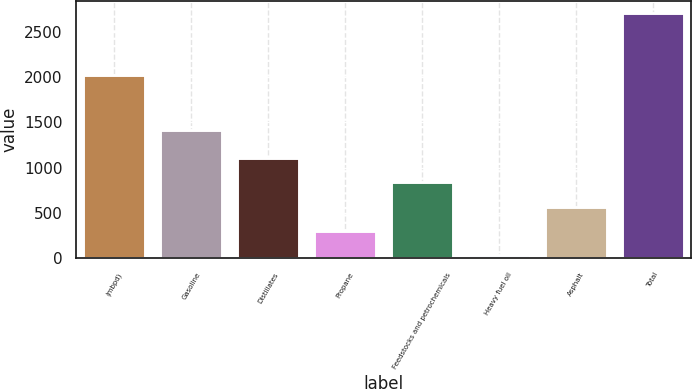<chart> <loc_0><loc_0><loc_500><loc_500><bar_chart><fcel>(mbpd)<fcel>Gasoline<fcel>Distillates<fcel>Propane<fcel>Feedstocks and petrochemicals<fcel>Heavy fuel oil<fcel>Asphalt<fcel>Total<nl><fcel>2018<fcel>1416<fcel>1103.4<fcel>303.6<fcel>836.8<fcel>37<fcel>570.2<fcel>2703<nl></chart> 